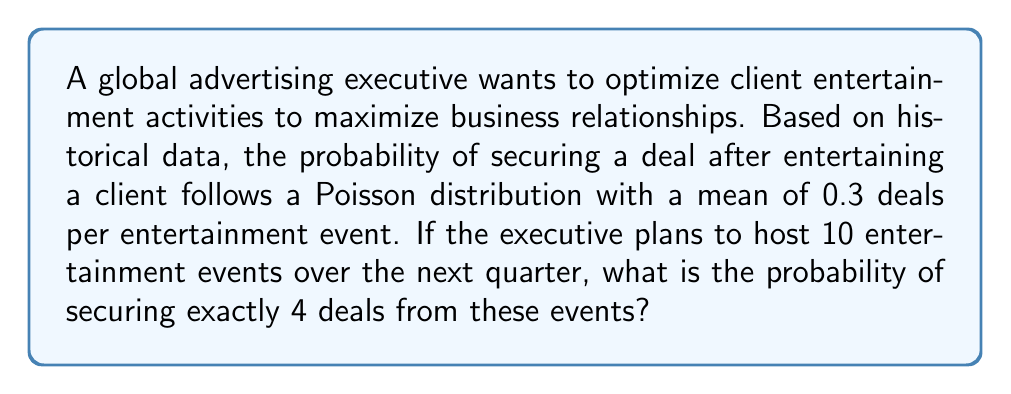Help me with this question. Let's approach this step-by-step:

1) The situation follows a Poisson distribution with a mean of $\lambda = 0.3$ deals per event.

2) We want to find the probability of exactly 4 deals in 10 events.

3) For 10 events, the mean number of deals becomes $\lambda' = 10 \times 0.3 = 3$.

4) The Poisson probability mass function is:

   $$P(X = k) = \frac{e^{-\lambda} \lambda^k}{k!}$$

   where $\lambda$ is the mean and $k$ is the number of occurrences.

5) In this case, $\lambda = 3$ and $k = 4$. Let's substitute these values:

   $$P(X = 4) = \frac{e^{-3} 3^4}{4!}$$

6) Now, let's calculate:
   
   $$P(X = 4) = \frac{e^{-3} \times 81}{24}$$

7) Using a calculator:
   
   $$P(X = 4) \approx 0.1680$$

8) Therefore, the probability of securing exactly 4 deals from 10 entertainment events is approximately 0.1680 or 16.80%.
Answer: 0.1680 